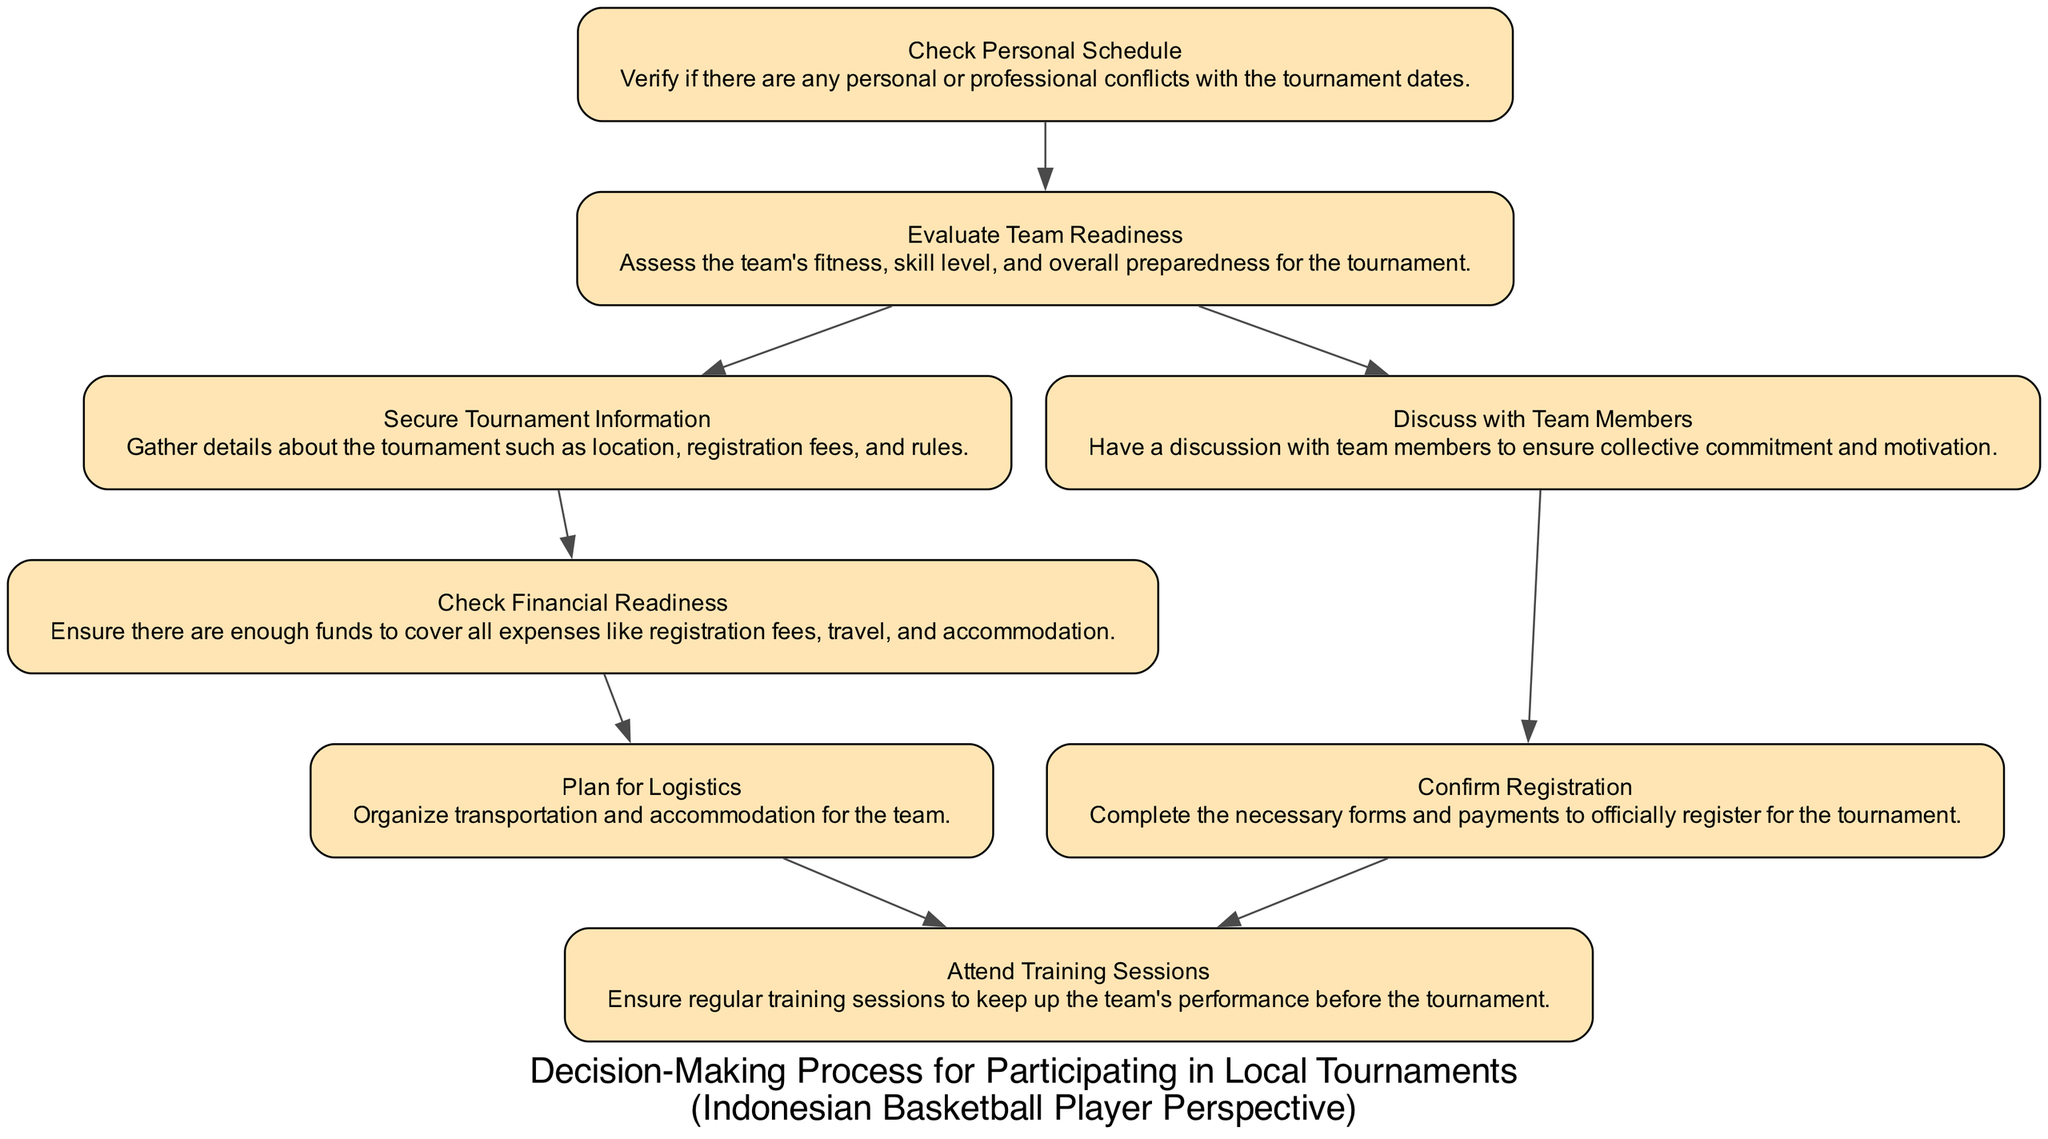What's the first step in the decision-making process? The first step in the process is "Check Personal Schedule," which verifies any personal or professional conflicts with the tournament dates.
Answer: Check Personal Schedule How many nodes are there in the diagram? By counting all the unique steps represented in the diagram, there are a total of eight nodes in the process.
Answer: Eight What is the last step in the decision-making process? The last step is "Attend Training Sessions," which emphasizes the importance of regular training before the tournament.
Answer: Attend Training Sessions Which step comes after "Secure Tournament Information"? Following "Secure Tournament Information," the next step is "Check Financial Readiness," where financial aspects are evaluated.
Answer: Check Financial Readiness What step involves team members' collective commitment? The step that involves discussing with team members to ensure collective commitment and motivation is named "Discuss with Team Members."
Answer: Discuss with Team Members If the team is not ready, what would be the next step according to the flow? If the team is not ready, the flow suggests going to "Discuss with Team Members," indicating teamwork and communication to address readiness issues.
Answer: Discuss with Team Members How many edges connect from "Evaluate Team Readiness"? From "Evaluate Team Readiness," there are two edges leading to two different next steps, namely "Secure Tournament Information" and "Discuss with Team Members."
Answer: Two What does the step "Plan for Logistics" entail? "Plan for Logistics" involves organizing transportation and accommodation for the team, ensuring their travel and stay are settled for the tournament.
Answer: Organize transportation and accommodation Which two steps connect to "Check Financial Readiness"? The only step that connects to "Check Financial Readiness" is "Secure Tournament Information," indicating that financial checks follow after gathering tournament details.
Answer: Secure Tournament Information What is the main focus of the node "Attend Training Sessions"? The main focus of this node is to ensure that the team participates in regular training sessions to maintain performance before the tournament.
Answer: Regular training sessions 